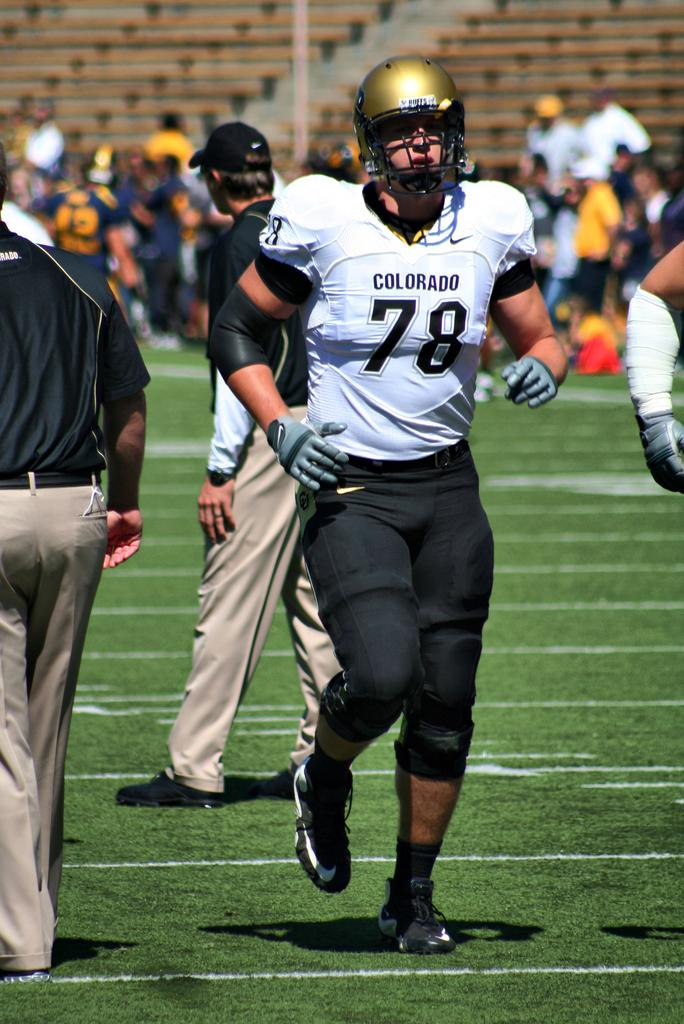Where was the image taken? The image was taken in a stadium. What are the people in the image doing? The people in the image are standing and walking on the ground. Can you describe the activity of the person in the foreground? In the foreground, there is a person running on the ground. What type of straw is being used by the person running in the foreground? There is no straw present in the image; the person running is not using any straw. 